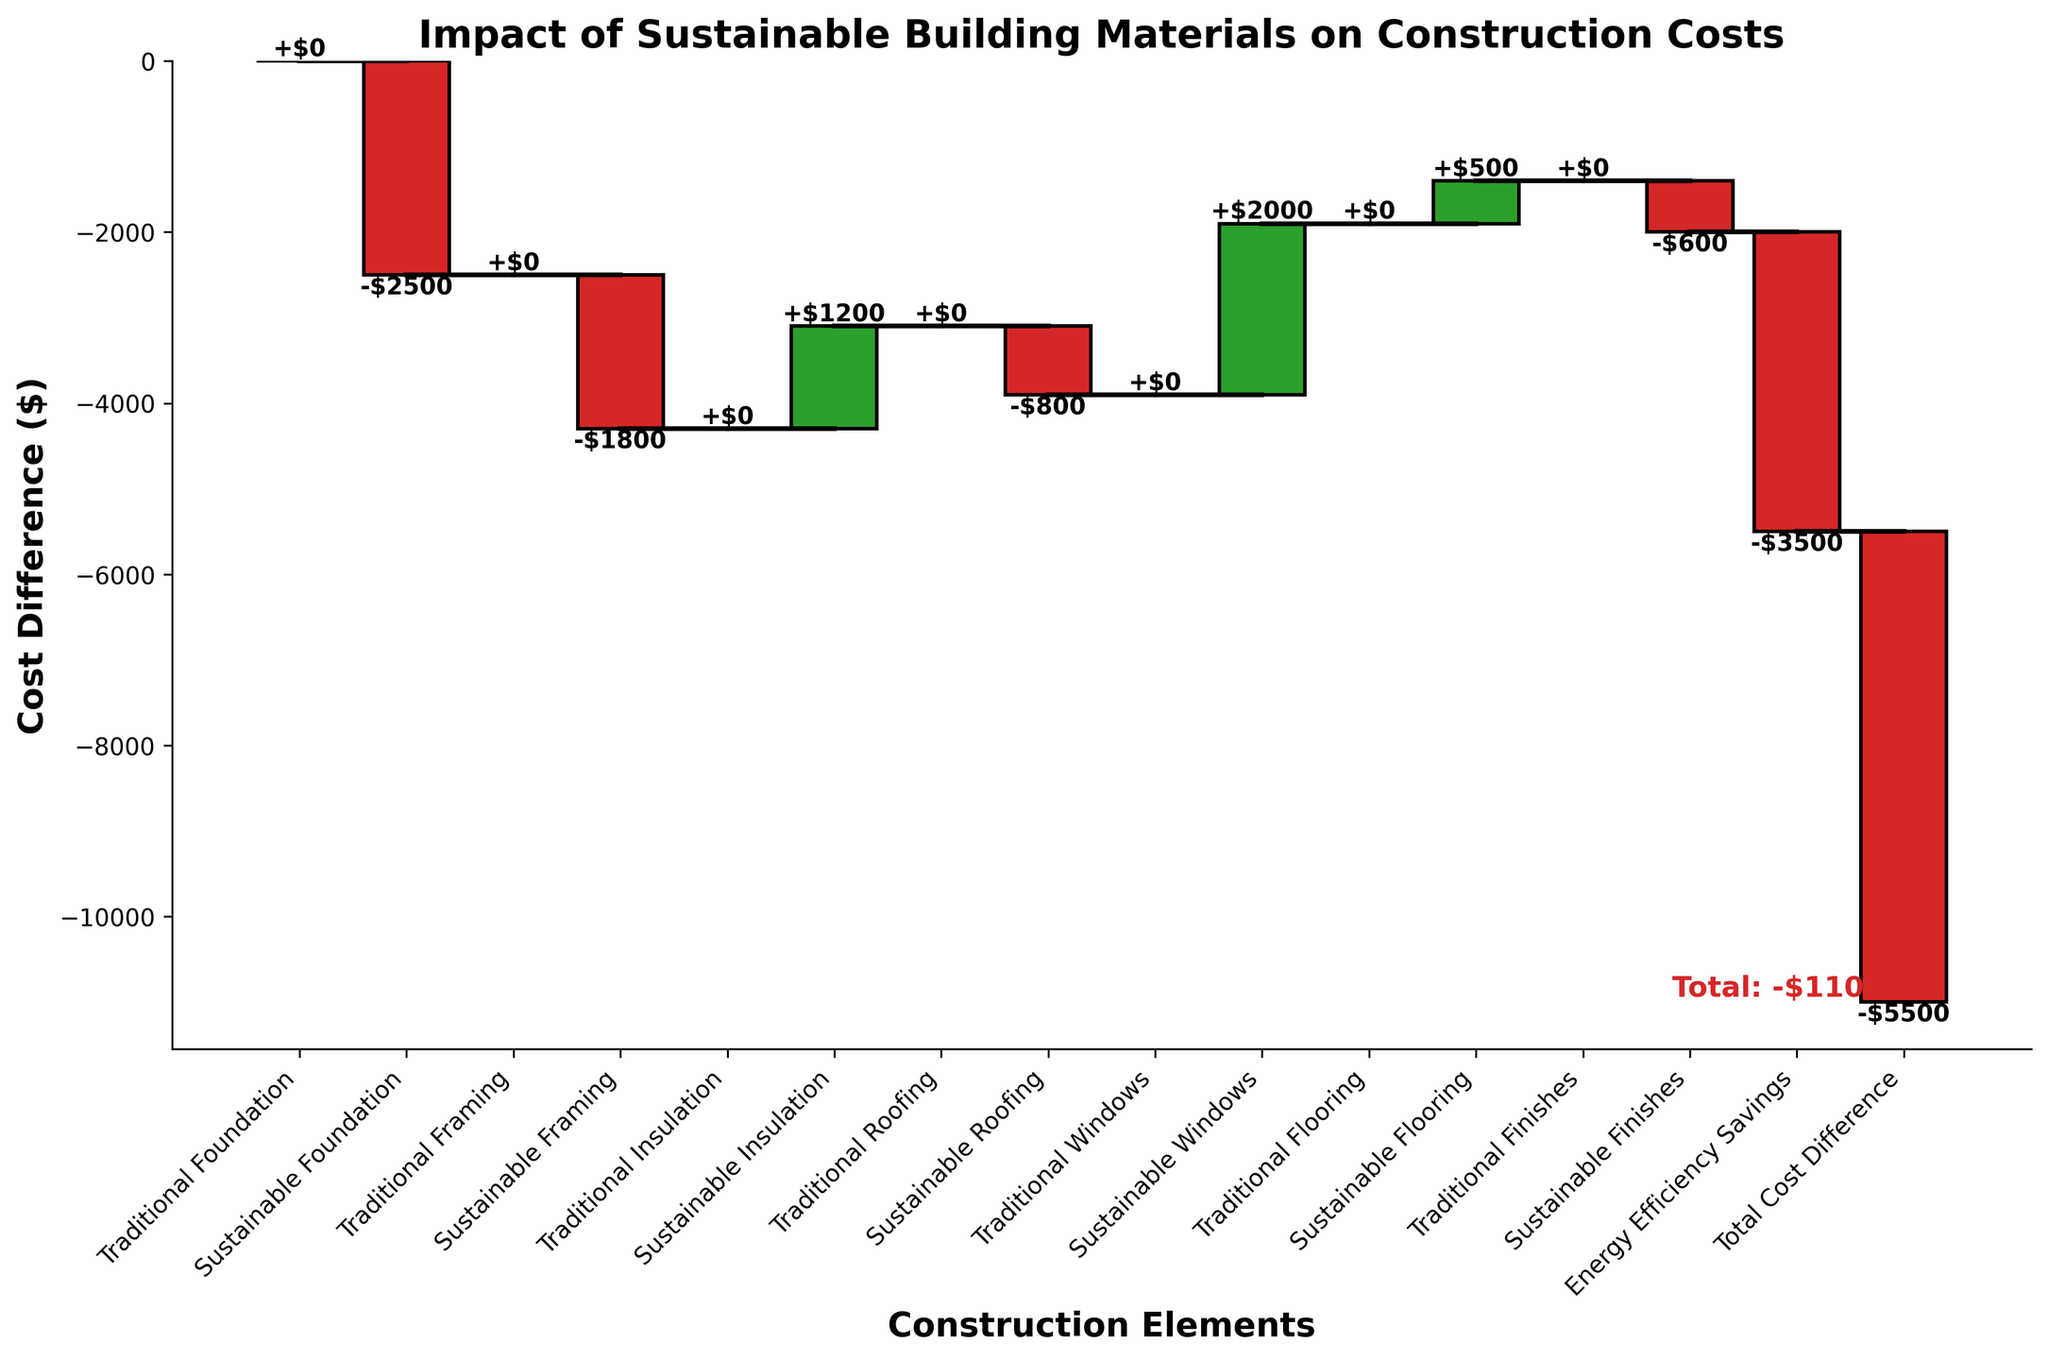What is the title of the chart? The title of the chart is displayed at the top and gives an overview of the chart's subject. In this case, it is "Impact of Sustainable Building Materials on Construction Costs."
Answer: Impact of Sustainable Building Materials on Construction Costs What is the total cost difference indicated at the end of the chart? The total cost difference is labeled at the end of the waterfall chart and is the cumulative result of all the value changes depicted. It is shown as "Total: -$5500."
Answer: -$5500 Which category shows the highest cost increase when using sustainable materials? To find the highest cost increase, look for the largest positive value in the waterfall chart. "Sustainable Windows" shows a cost increase of $2000.
Answer: Sustainable Windows Which element contributed the most to cost savings in the use of sustainable materials? To find the largest cost-saving element, identify the most negative value in the chart. "Energy Efficiency Savings" shows the largest cost saving with -$3500.
Answer: Energy Efficiency Savings What is the net cost impact of sustainable insulation? Look for the value associated with "Sustainable Insulation" in the chart, which is $1200. This indicates a net cost increase of $1200.
Answer: $1200 What's the cumulative impact on costs up to the sustainable framing stage? Sum the values from "Sustainable Foundation" and "Sustainable Framing" (-2500 + -1800). The cumulative impact is -$4300.
Answer: -$4300 How does the cost impact of sustainable flooring compare to sustainable finishes? Compare the values: "Sustainable Flooring" is $500 and "Sustainable Finishes" is -$600. Flooring has a higher cost by $1100.
Answer: $1100 What is the overall difference between traditional and sustainable construction after considering energy efficiency savings? The overall difference is shown as the "Total Cost Difference" at the end of the chart, which includes energy efficiency savings. This total is -$5500.
Answer: -$5500 How many distinct construction elements are compared in the chart? Count the number of categories in the chart excluding energy efficiency savings and total cost difference. There are 8 distinct elements: Foundation, Framing, Insulation, Roofing, Windows, Flooring, Finishes.
Answer: 8 